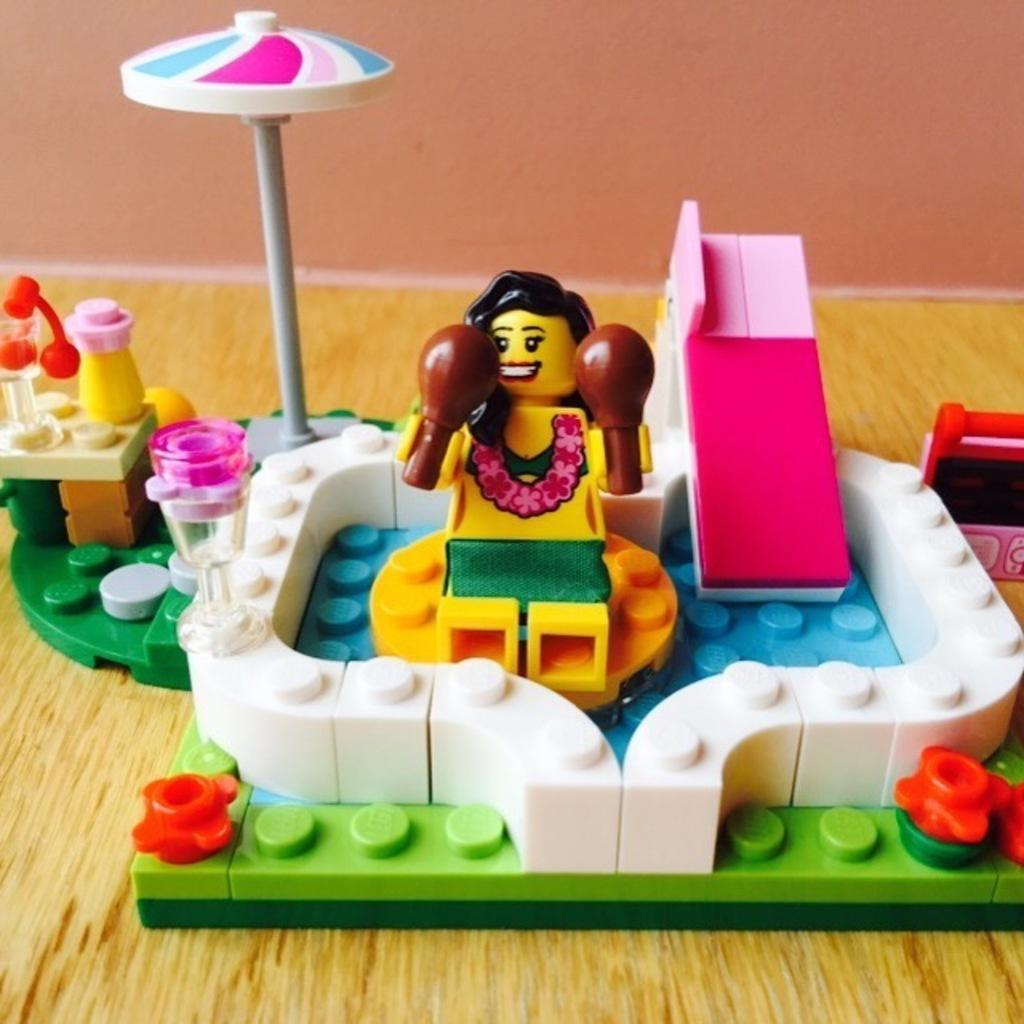What objects are on the floor in the image? There are toys on the floor in the image. Where is the throne located in the image? There is no throne present in the image. What role does the porter play in the image? There is no porter present in the image. 